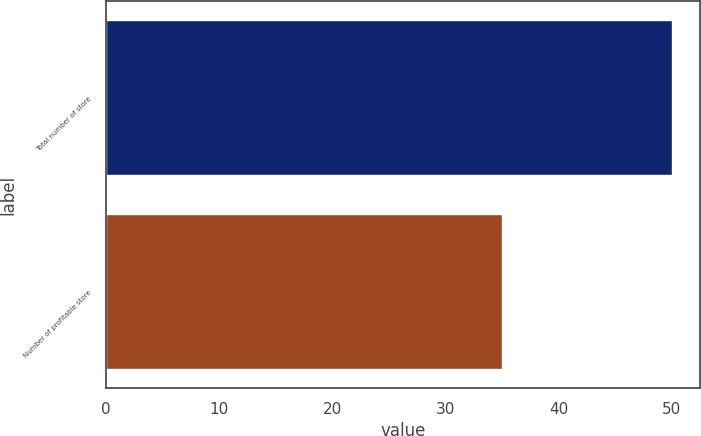<chart> <loc_0><loc_0><loc_500><loc_500><bar_chart><fcel>Total number of store<fcel>Number of profitable store<nl><fcel>50<fcel>35<nl></chart> 